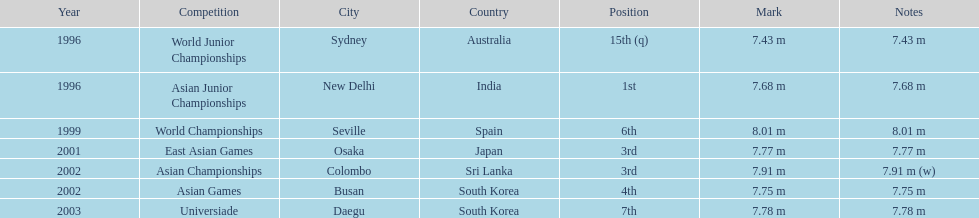How long was huang le's longest jump in 2002? 7.91 m (w). 